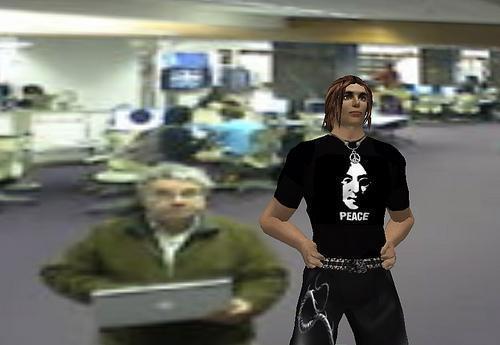How many people are in the photo?
Give a very brief answer. 2. 